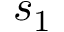Convert formula to latex. <formula><loc_0><loc_0><loc_500><loc_500>s _ { 1 }</formula> 